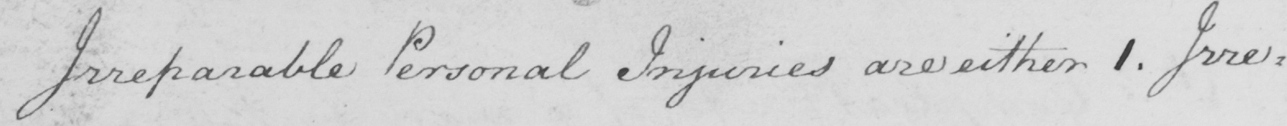Can you tell me what this handwritten text says? Irreparable Personal Injuries are either 1. Irre= 